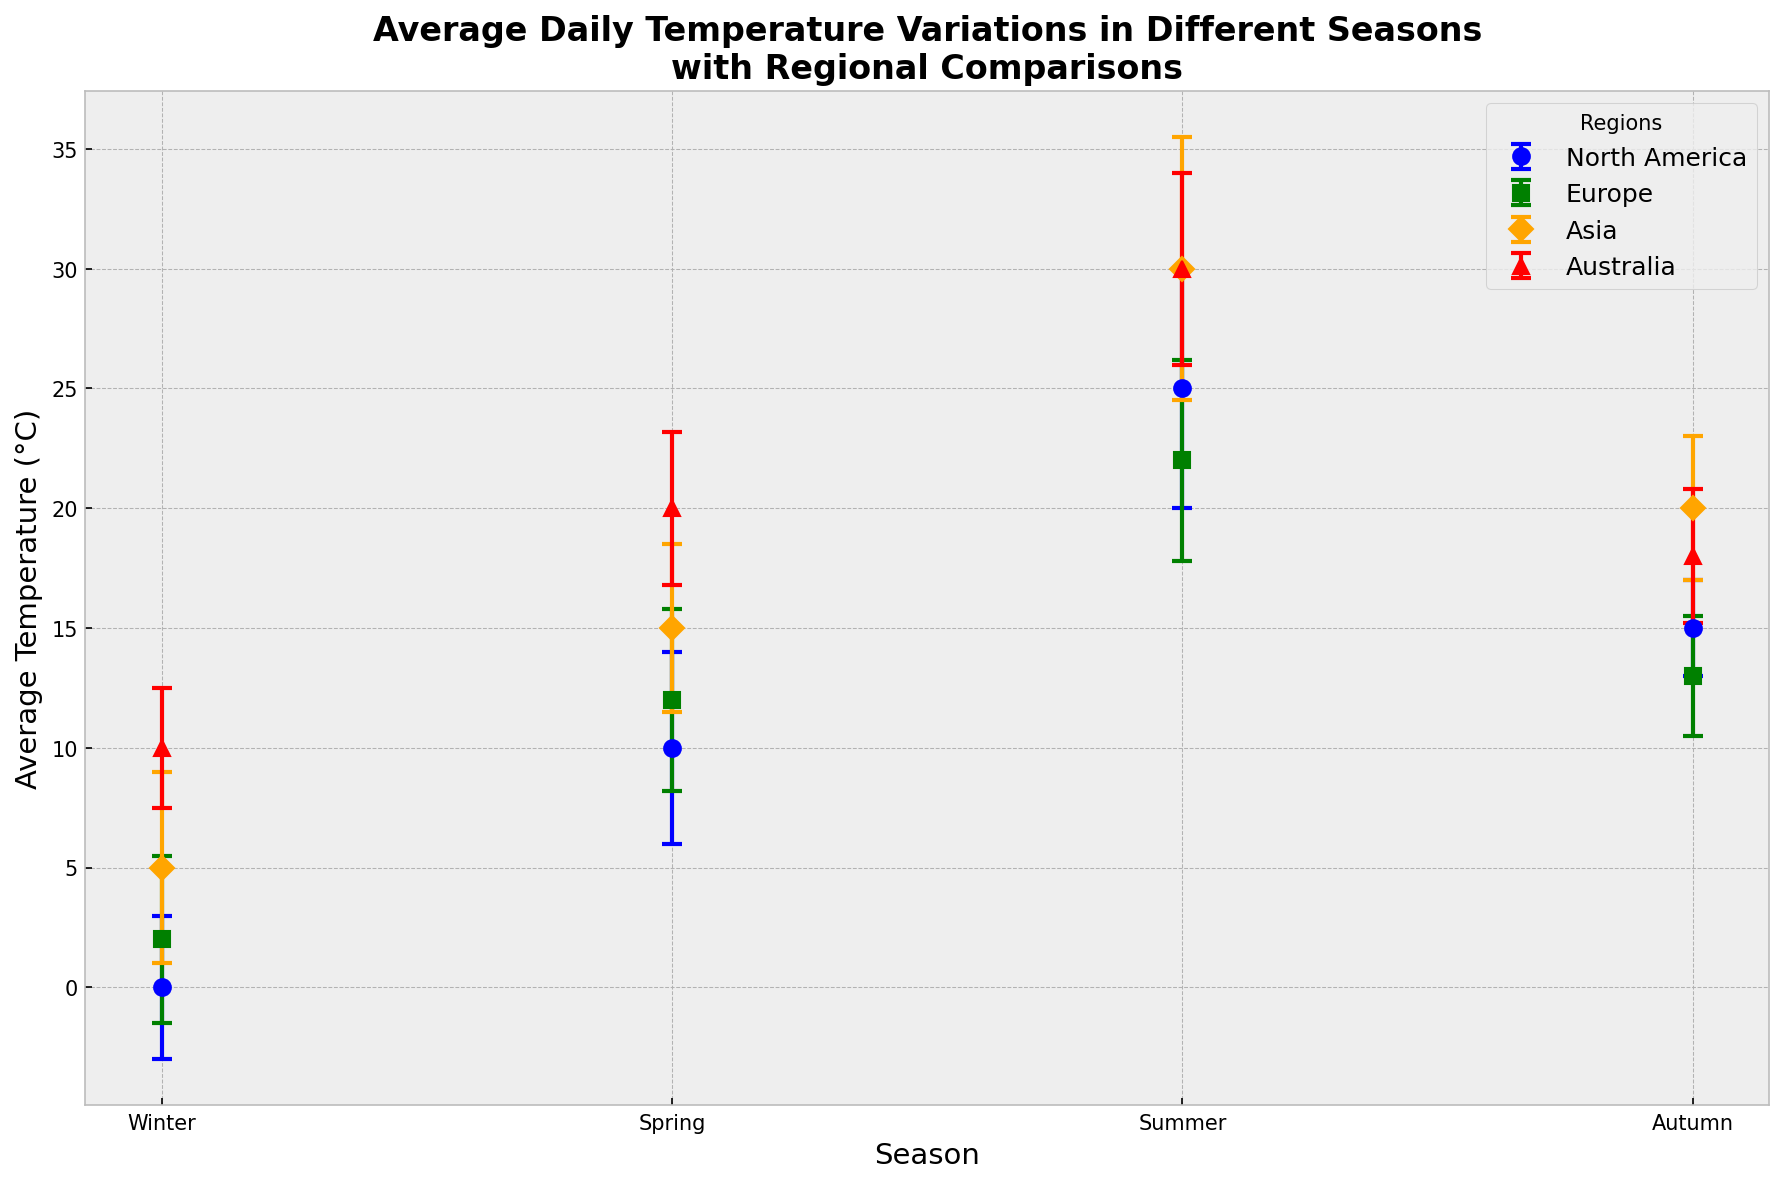Which region has the highest average temperature in winter? Look at the points on the graph labeled "Winter" and identify the region with the highest point. Asia has the highest average winter temperature at 5°C.
Answer: Asia What is the difference in average temperature between Spring and Summer in Europe? Locate the data points for Europe for Spring and Summer on the graph. Spring is 12°C and Summer is 22°C. The difference is 22°C - 12°C = 10°C.
Answer: 10°C Which region has the smallest standard deviation for any season? Identify the error bars on the graph and find the smallest one. Australia in Winter has the smallest standard deviation, 2.5°C.
Answer: Australia in Winter Is the average temperature in Summer higher in Europe or North America? Compare the points for Summer in Europe and North America. Europe has 22°C and North America has 25°C. North America has a higher average summer temperature.
Answer: North America What’s the total average temperature across all seasons in North America? Add the average temperatures for all seasons in North America: Winter (0°C), Spring (10°C), Summer (25°C), Autumn (15°C). Total: 0 + 10 + 25 + 15 = 50°C.
Answer: 50°C Which season shows the largest variability in average temperatures across different regions? Compare the length of the error bars for each season across all regions. Summer has the largest variability: Asia has ±5.5°C and Europe has ±4.2°C, among others.
Answer: Summer Are the average temperatures in Autumn for Asia and Europe within each other's standard deviations? For Europe, the temperature is 13°C with a std of ±2.5°C, making the range 10.5°C to 15.5°C. For Asia, it’s 20°C with a std of ±3°C, making the range 17°C to 23°C. There's no overlap.
Answer: No Which region has the coolest average temperature during Spring? Look at the points labeled "Spring" for each region. North America has the lowest point at 10°C.
Answer: North America How much higher is the average temperature in Summer in Asia compared to North America? Locate the Summer points for both Asia and North America: Asia (30°C) and North America (25°C). The difference is 30°C - 25°C = 5°C.
Answer: 5°C 